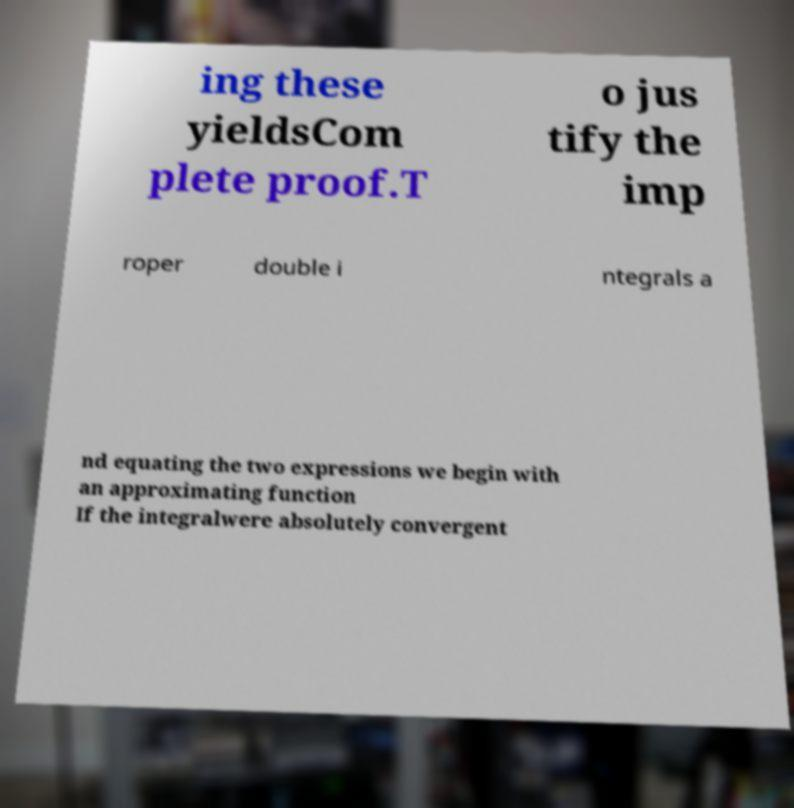There's text embedded in this image that I need extracted. Can you transcribe it verbatim? ing these yieldsCom plete proof.T o jus tify the imp roper double i ntegrals a nd equating the two expressions we begin with an approximating function If the integralwere absolutely convergent 